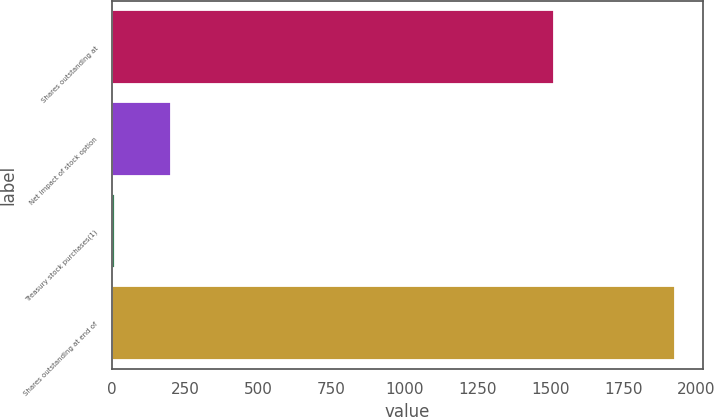Convert chart to OTSL. <chart><loc_0><loc_0><loc_500><loc_500><bar_chart><fcel>Shares outstanding at<fcel>Net impact of stock option<fcel>Treasury stock purchases(1)<fcel>Shares outstanding at end of<nl><fcel>1512<fcel>202.6<fcel>11<fcel>1927<nl></chart> 